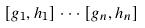<formula> <loc_0><loc_0><loc_500><loc_500>[ g _ { 1 } , h _ { 1 } ] \cdot \cdot \cdot [ g _ { n } , h _ { n } ]</formula> 